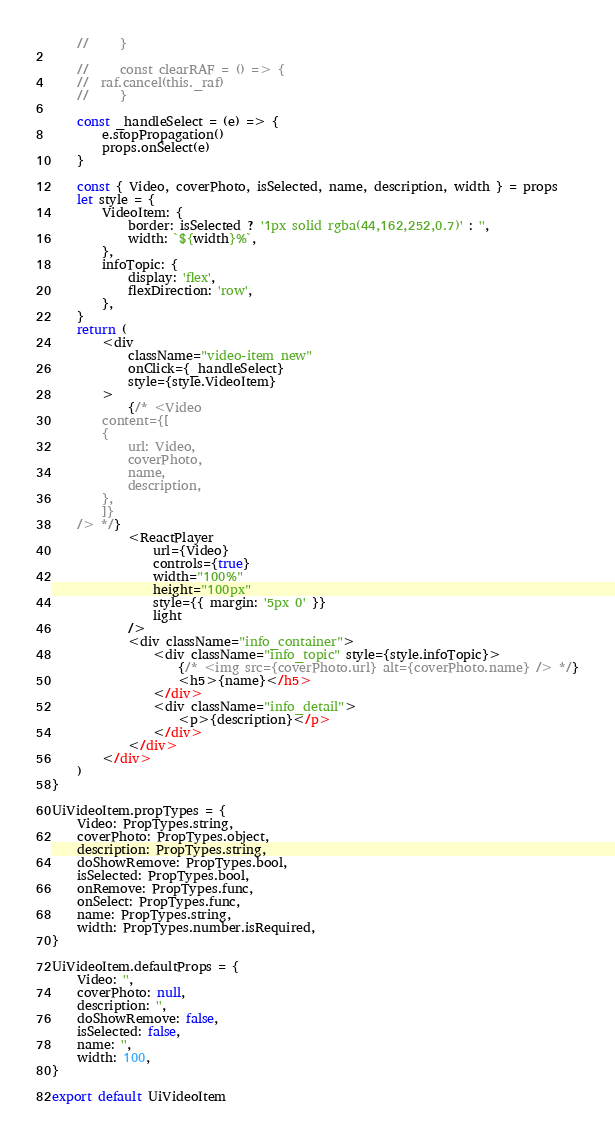<code> <loc_0><loc_0><loc_500><loc_500><_JavaScript_>    //     }

    //     const clearRAF = () => {
    // 	raf.cancel(this._raf)
    //     }

    const _handleSelect = (e) => {
        e.stopPropagation()
        props.onSelect(e)
    }

    const { Video, coverPhoto, isSelected, name, description, width } = props
    let style = {
        VideoItem: {
            border: isSelected ? '1px solid rgba(44,162,252,0.7)' : '',
            width: `${width}%`,
        },
        infoTopic: {
            display: 'flex',
            flexDirection: 'row',
        },
    }
    return (
        <div
            className="video-item new"
            onClick={_handleSelect}
            style={style.VideoItem}
        >
            {/* <Video
	    content={[
		{
		    url: Video,
		    coverPhoto,
		    name,
		    description,
		},
	    ]}
	/> */}
            <ReactPlayer
                url={Video}
                controls={true}
                width="100%"
                height="100px"
                style={{ margin: '5px 0' }}
                light
            />
            <div className="info_container">
                <div className="info_topic" style={style.infoTopic}>
                    {/* <img src={coverPhoto.url} alt={coverPhoto.name} /> */}
                    <h5>{name}</h5>
                </div>
                <div className="info_detail">
                    <p>{description}</p>
                </div>
            </div>
        </div>
    )
}

UiVideoItem.propTypes = {
    Video: PropTypes.string,
    coverPhoto: PropTypes.object,
    description: PropTypes.string,
    doShowRemove: PropTypes.bool,
    isSelected: PropTypes.bool,
    onRemove: PropTypes.func,
    onSelect: PropTypes.func,
    name: PropTypes.string,
    width: PropTypes.number.isRequired,
}

UiVideoItem.defaultProps = {
    Video: '',
    coverPhoto: null,
    description: '',
    doShowRemove: false,
    isSelected: false,
    name: '',
    width: 100,
}

export default UiVideoItem
</code> 